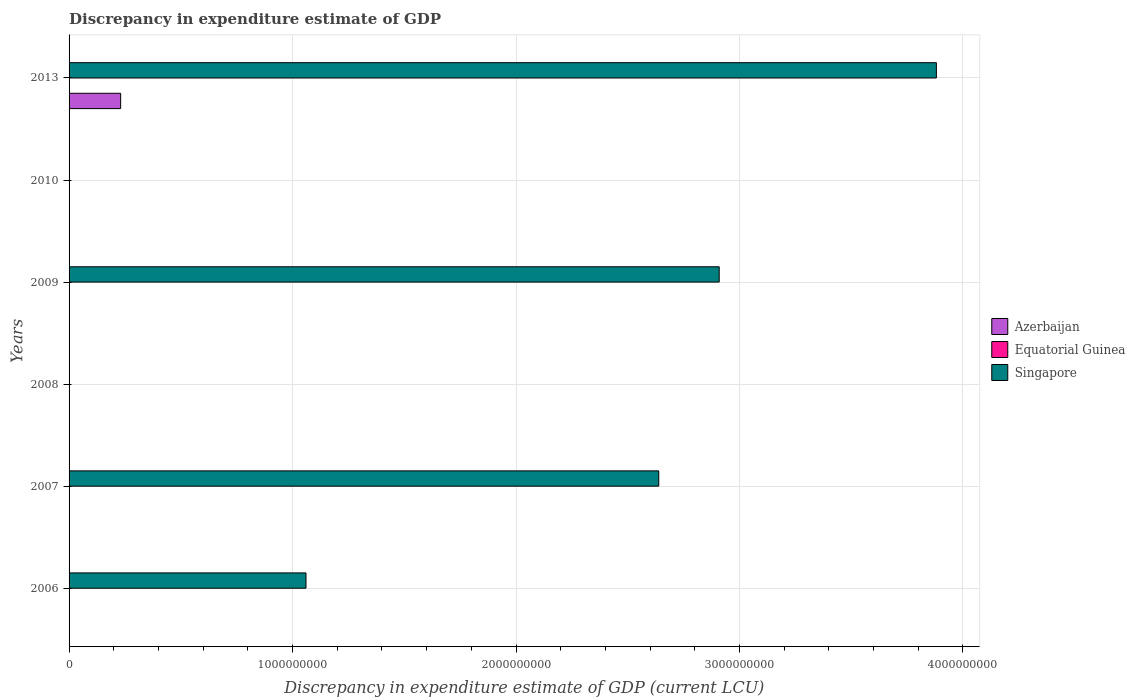How many different coloured bars are there?
Offer a terse response. 3. How many bars are there on the 5th tick from the top?
Your answer should be very brief. 2. What is the discrepancy in expenditure estimate of GDP in Azerbaijan in 2010?
Your response must be concise. 0. Across all years, what is the maximum discrepancy in expenditure estimate of GDP in Singapore?
Make the answer very short. 3.88e+09. In which year was the discrepancy in expenditure estimate of GDP in Equatorial Guinea maximum?
Ensure brevity in your answer.  2008. What is the total discrepancy in expenditure estimate of GDP in Singapore in the graph?
Your answer should be compact. 1.05e+1. What is the difference between the discrepancy in expenditure estimate of GDP in Equatorial Guinea in 2007 and that in 2009?
Offer a terse response. 0. What is the difference between the discrepancy in expenditure estimate of GDP in Singapore in 2006 and the discrepancy in expenditure estimate of GDP in Equatorial Guinea in 2008?
Make the answer very short. 1.06e+09. What is the average discrepancy in expenditure estimate of GDP in Azerbaijan per year?
Your answer should be compact. 3.85e+07. In the year 2013, what is the difference between the discrepancy in expenditure estimate of GDP in Azerbaijan and discrepancy in expenditure estimate of GDP in Equatorial Guinea?
Provide a short and direct response. 2.31e+08. In how many years, is the discrepancy in expenditure estimate of GDP in Equatorial Guinea greater than 2200000000 LCU?
Give a very brief answer. 0. What is the ratio of the discrepancy in expenditure estimate of GDP in Equatorial Guinea in 2007 to that in 2013?
Offer a very short reply. 4.656599099413718e-6. Is the discrepancy in expenditure estimate of GDP in Equatorial Guinea in 2007 less than that in 2013?
Provide a short and direct response. Yes. What is the difference between the highest and the second highest discrepancy in expenditure estimate of GDP in Singapore?
Make the answer very short. 9.72e+08. What is the difference between the highest and the lowest discrepancy in expenditure estimate of GDP in Equatorial Guinea?
Provide a short and direct response. 100. In how many years, is the discrepancy in expenditure estimate of GDP in Equatorial Guinea greater than the average discrepancy in expenditure estimate of GDP in Equatorial Guinea taken over all years?
Your answer should be compact. 2. Is the sum of the discrepancy in expenditure estimate of GDP in Singapore in 2006 and 2007 greater than the maximum discrepancy in expenditure estimate of GDP in Equatorial Guinea across all years?
Provide a succinct answer. Yes. Are all the bars in the graph horizontal?
Your response must be concise. Yes. Does the graph contain any zero values?
Offer a terse response. Yes. Does the graph contain grids?
Your answer should be very brief. Yes. How many legend labels are there?
Provide a short and direct response. 3. What is the title of the graph?
Keep it short and to the point. Discrepancy in expenditure estimate of GDP. What is the label or title of the X-axis?
Your response must be concise. Discrepancy in expenditure estimate of GDP (current LCU). What is the Discrepancy in expenditure estimate of GDP (current LCU) of Equatorial Guinea in 2006?
Your response must be concise. 0. What is the Discrepancy in expenditure estimate of GDP (current LCU) of Singapore in 2006?
Make the answer very short. 1.06e+09. What is the Discrepancy in expenditure estimate of GDP (current LCU) in Azerbaijan in 2007?
Ensure brevity in your answer.  0. What is the Discrepancy in expenditure estimate of GDP (current LCU) of Equatorial Guinea in 2007?
Offer a terse response. 0. What is the Discrepancy in expenditure estimate of GDP (current LCU) of Singapore in 2007?
Provide a short and direct response. 2.64e+09. What is the Discrepancy in expenditure estimate of GDP (current LCU) in Azerbaijan in 2008?
Keep it short and to the point. 0. What is the Discrepancy in expenditure estimate of GDP (current LCU) of Equatorial Guinea in 2008?
Your answer should be compact. 100. What is the Discrepancy in expenditure estimate of GDP (current LCU) in Azerbaijan in 2009?
Provide a succinct answer. 0. What is the Discrepancy in expenditure estimate of GDP (current LCU) of Equatorial Guinea in 2009?
Make the answer very short. 0. What is the Discrepancy in expenditure estimate of GDP (current LCU) of Singapore in 2009?
Your response must be concise. 2.91e+09. What is the Discrepancy in expenditure estimate of GDP (current LCU) in Azerbaijan in 2010?
Give a very brief answer. 0. What is the Discrepancy in expenditure estimate of GDP (current LCU) in Singapore in 2010?
Offer a terse response. 0. What is the Discrepancy in expenditure estimate of GDP (current LCU) in Azerbaijan in 2013?
Your answer should be compact. 2.31e+08. What is the Discrepancy in expenditure estimate of GDP (current LCU) of Equatorial Guinea in 2013?
Give a very brief answer. 100. What is the Discrepancy in expenditure estimate of GDP (current LCU) in Singapore in 2013?
Offer a terse response. 3.88e+09. Across all years, what is the maximum Discrepancy in expenditure estimate of GDP (current LCU) of Azerbaijan?
Your answer should be compact. 2.31e+08. Across all years, what is the maximum Discrepancy in expenditure estimate of GDP (current LCU) of Equatorial Guinea?
Your response must be concise. 100. Across all years, what is the maximum Discrepancy in expenditure estimate of GDP (current LCU) of Singapore?
Offer a very short reply. 3.88e+09. Across all years, what is the minimum Discrepancy in expenditure estimate of GDP (current LCU) of Singapore?
Give a very brief answer. 0. What is the total Discrepancy in expenditure estimate of GDP (current LCU) in Azerbaijan in the graph?
Offer a very short reply. 2.31e+08. What is the total Discrepancy in expenditure estimate of GDP (current LCU) of Equatorial Guinea in the graph?
Provide a short and direct response. 200. What is the total Discrepancy in expenditure estimate of GDP (current LCU) of Singapore in the graph?
Offer a terse response. 1.05e+1. What is the difference between the Discrepancy in expenditure estimate of GDP (current LCU) in Equatorial Guinea in 2006 and that in 2007?
Give a very brief answer. 0. What is the difference between the Discrepancy in expenditure estimate of GDP (current LCU) in Singapore in 2006 and that in 2007?
Offer a very short reply. -1.58e+09. What is the difference between the Discrepancy in expenditure estimate of GDP (current LCU) of Equatorial Guinea in 2006 and that in 2008?
Offer a terse response. -100. What is the difference between the Discrepancy in expenditure estimate of GDP (current LCU) in Singapore in 2006 and that in 2009?
Give a very brief answer. -1.85e+09. What is the difference between the Discrepancy in expenditure estimate of GDP (current LCU) in Equatorial Guinea in 2006 and that in 2013?
Your answer should be compact. -100. What is the difference between the Discrepancy in expenditure estimate of GDP (current LCU) of Singapore in 2006 and that in 2013?
Your answer should be very brief. -2.82e+09. What is the difference between the Discrepancy in expenditure estimate of GDP (current LCU) of Equatorial Guinea in 2007 and that in 2008?
Your answer should be compact. -100. What is the difference between the Discrepancy in expenditure estimate of GDP (current LCU) of Equatorial Guinea in 2007 and that in 2009?
Keep it short and to the point. 0. What is the difference between the Discrepancy in expenditure estimate of GDP (current LCU) in Singapore in 2007 and that in 2009?
Give a very brief answer. -2.70e+08. What is the difference between the Discrepancy in expenditure estimate of GDP (current LCU) in Equatorial Guinea in 2007 and that in 2013?
Keep it short and to the point. -100. What is the difference between the Discrepancy in expenditure estimate of GDP (current LCU) in Singapore in 2007 and that in 2013?
Your answer should be very brief. -1.24e+09. What is the difference between the Discrepancy in expenditure estimate of GDP (current LCU) of Equatorial Guinea in 2008 and that in 2009?
Keep it short and to the point. 100. What is the difference between the Discrepancy in expenditure estimate of GDP (current LCU) of Equatorial Guinea in 2008 and that in 2013?
Your answer should be compact. 0. What is the difference between the Discrepancy in expenditure estimate of GDP (current LCU) of Equatorial Guinea in 2009 and that in 2013?
Your response must be concise. -100. What is the difference between the Discrepancy in expenditure estimate of GDP (current LCU) in Singapore in 2009 and that in 2013?
Offer a terse response. -9.72e+08. What is the difference between the Discrepancy in expenditure estimate of GDP (current LCU) in Equatorial Guinea in 2006 and the Discrepancy in expenditure estimate of GDP (current LCU) in Singapore in 2007?
Offer a terse response. -2.64e+09. What is the difference between the Discrepancy in expenditure estimate of GDP (current LCU) in Equatorial Guinea in 2006 and the Discrepancy in expenditure estimate of GDP (current LCU) in Singapore in 2009?
Your answer should be very brief. -2.91e+09. What is the difference between the Discrepancy in expenditure estimate of GDP (current LCU) of Equatorial Guinea in 2006 and the Discrepancy in expenditure estimate of GDP (current LCU) of Singapore in 2013?
Ensure brevity in your answer.  -3.88e+09. What is the difference between the Discrepancy in expenditure estimate of GDP (current LCU) of Equatorial Guinea in 2007 and the Discrepancy in expenditure estimate of GDP (current LCU) of Singapore in 2009?
Provide a succinct answer. -2.91e+09. What is the difference between the Discrepancy in expenditure estimate of GDP (current LCU) of Equatorial Guinea in 2007 and the Discrepancy in expenditure estimate of GDP (current LCU) of Singapore in 2013?
Ensure brevity in your answer.  -3.88e+09. What is the difference between the Discrepancy in expenditure estimate of GDP (current LCU) of Equatorial Guinea in 2008 and the Discrepancy in expenditure estimate of GDP (current LCU) of Singapore in 2009?
Provide a short and direct response. -2.91e+09. What is the difference between the Discrepancy in expenditure estimate of GDP (current LCU) in Equatorial Guinea in 2008 and the Discrepancy in expenditure estimate of GDP (current LCU) in Singapore in 2013?
Offer a very short reply. -3.88e+09. What is the difference between the Discrepancy in expenditure estimate of GDP (current LCU) in Equatorial Guinea in 2009 and the Discrepancy in expenditure estimate of GDP (current LCU) in Singapore in 2013?
Make the answer very short. -3.88e+09. What is the average Discrepancy in expenditure estimate of GDP (current LCU) of Azerbaijan per year?
Your answer should be very brief. 3.85e+07. What is the average Discrepancy in expenditure estimate of GDP (current LCU) in Equatorial Guinea per year?
Provide a succinct answer. 33.33. What is the average Discrepancy in expenditure estimate of GDP (current LCU) in Singapore per year?
Provide a short and direct response. 1.75e+09. In the year 2006, what is the difference between the Discrepancy in expenditure estimate of GDP (current LCU) in Equatorial Guinea and Discrepancy in expenditure estimate of GDP (current LCU) in Singapore?
Keep it short and to the point. -1.06e+09. In the year 2007, what is the difference between the Discrepancy in expenditure estimate of GDP (current LCU) in Equatorial Guinea and Discrepancy in expenditure estimate of GDP (current LCU) in Singapore?
Offer a terse response. -2.64e+09. In the year 2009, what is the difference between the Discrepancy in expenditure estimate of GDP (current LCU) of Equatorial Guinea and Discrepancy in expenditure estimate of GDP (current LCU) of Singapore?
Ensure brevity in your answer.  -2.91e+09. In the year 2013, what is the difference between the Discrepancy in expenditure estimate of GDP (current LCU) in Azerbaijan and Discrepancy in expenditure estimate of GDP (current LCU) in Equatorial Guinea?
Keep it short and to the point. 2.31e+08. In the year 2013, what is the difference between the Discrepancy in expenditure estimate of GDP (current LCU) of Azerbaijan and Discrepancy in expenditure estimate of GDP (current LCU) of Singapore?
Provide a short and direct response. -3.65e+09. In the year 2013, what is the difference between the Discrepancy in expenditure estimate of GDP (current LCU) in Equatorial Guinea and Discrepancy in expenditure estimate of GDP (current LCU) in Singapore?
Ensure brevity in your answer.  -3.88e+09. What is the ratio of the Discrepancy in expenditure estimate of GDP (current LCU) of Equatorial Guinea in 2006 to that in 2007?
Give a very brief answer. 1.25. What is the ratio of the Discrepancy in expenditure estimate of GDP (current LCU) of Singapore in 2006 to that in 2007?
Offer a very short reply. 0.4. What is the ratio of the Discrepancy in expenditure estimate of GDP (current LCU) in Equatorial Guinea in 2006 to that in 2008?
Offer a terse response. 0. What is the ratio of the Discrepancy in expenditure estimate of GDP (current LCU) of Singapore in 2006 to that in 2009?
Make the answer very short. 0.36. What is the ratio of the Discrepancy in expenditure estimate of GDP (current LCU) of Equatorial Guinea in 2006 to that in 2013?
Provide a succinct answer. 0. What is the ratio of the Discrepancy in expenditure estimate of GDP (current LCU) of Singapore in 2006 to that in 2013?
Give a very brief answer. 0.27. What is the ratio of the Discrepancy in expenditure estimate of GDP (current LCU) in Singapore in 2007 to that in 2009?
Offer a very short reply. 0.91. What is the ratio of the Discrepancy in expenditure estimate of GDP (current LCU) in Equatorial Guinea in 2007 to that in 2013?
Offer a very short reply. 0. What is the ratio of the Discrepancy in expenditure estimate of GDP (current LCU) of Singapore in 2007 to that in 2013?
Offer a very short reply. 0.68. What is the ratio of the Discrepancy in expenditure estimate of GDP (current LCU) of Equatorial Guinea in 2008 to that in 2009?
Provide a short and direct response. 2.86e+05. What is the ratio of the Discrepancy in expenditure estimate of GDP (current LCU) of Singapore in 2009 to that in 2013?
Keep it short and to the point. 0.75. What is the difference between the highest and the second highest Discrepancy in expenditure estimate of GDP (current LCU) in Equatorial Guinea?
Provide a short and direct response. 0. What is the difference between the highest and the second highest Discrepancy in expenditure estimate of GDP (current LCU) in Singapore?
Make the answer very short. 9.72e+08. What is the difference between the highest and the lowest Discrepancy in expenditure estimate of GDP (current LCU) in Azerbaijan?
Ensure brevity in your answer.  2.31e+08. What is the difference between the highest and the lowest Discrepancy in expenditure estimate of GDP (current LCU) of Equatorial Guinea?
Offer a terse response. 100. What is the difference between the highest and the lowest Discrepancy in expenditure estimate of GDP (current LCU) of Singapore?
Ensure brevity in your answer.  3.88e+09. 